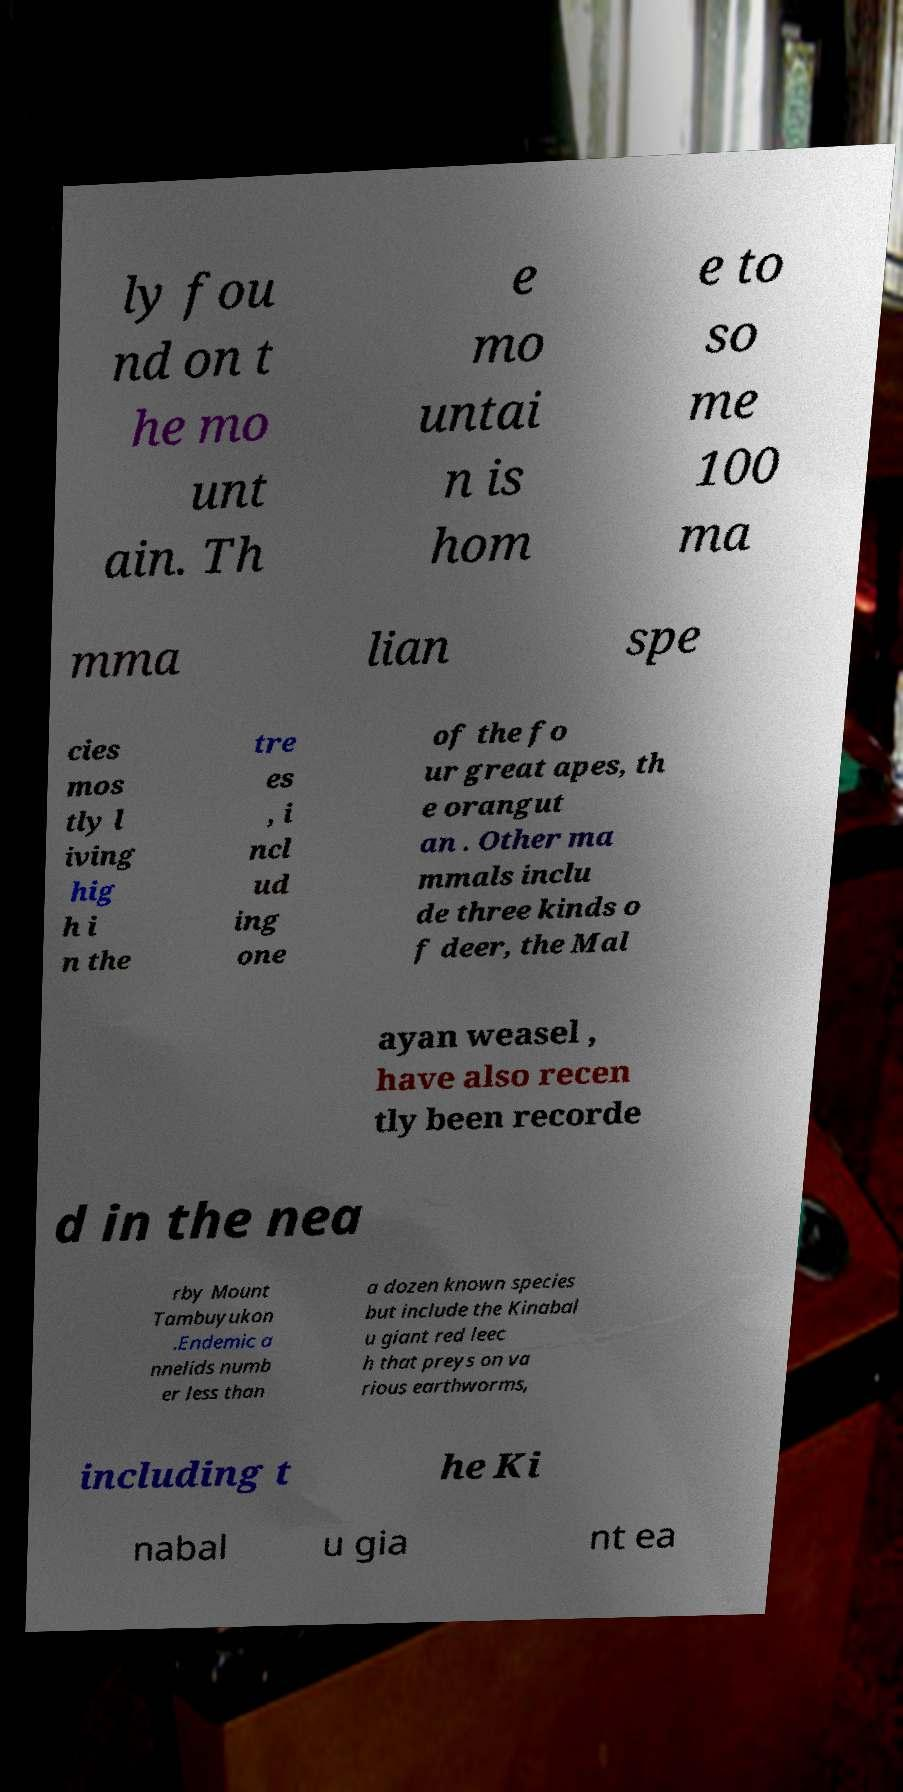I need the written content from this picture converted into text. Can you do that? ly fou nd on t he mo unt ain. Th e mo untai n is hom e to so me 100 ma mma lian spe cies mos tly l iving hig h i n the tre es , i ncl ud ing one of the fo ur great apes, th e orangut an . Other ma mmals inclu de three kinds o f deer, the Mal ayan weasel , have also recen tly been recorde d in the nea rby Mount Tambuyukon .Endemic a nnelids numb er less than a dozen known species but include the Kinabal u giant red leec h that preys on va rious earthworms, including t he Ki nabal u gia nt ea 